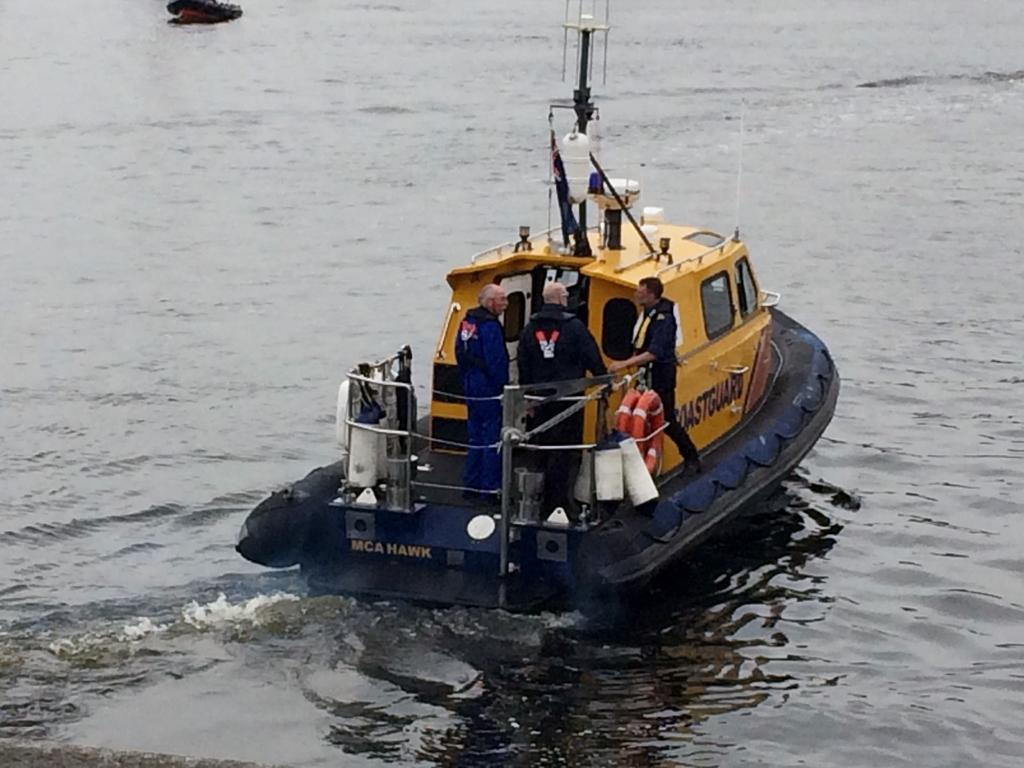How many people are in the image? There are three men in the image. What are the men doing in the image? The men are standing on a boat. Where is the boat located in the image? The boat is on the water. What type of hospital can be seen in the image? There is no hospital present in the image; it features three men standing on a boat on the water. 